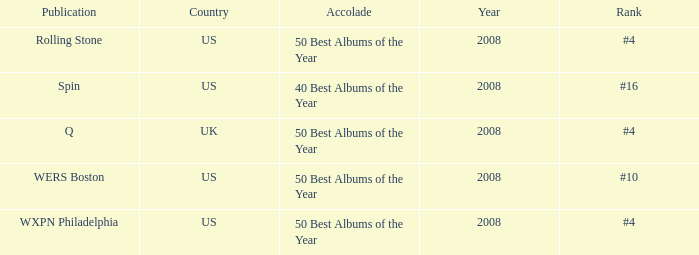Which year's rank was #4 when the country was the US? 2008, 2008. 